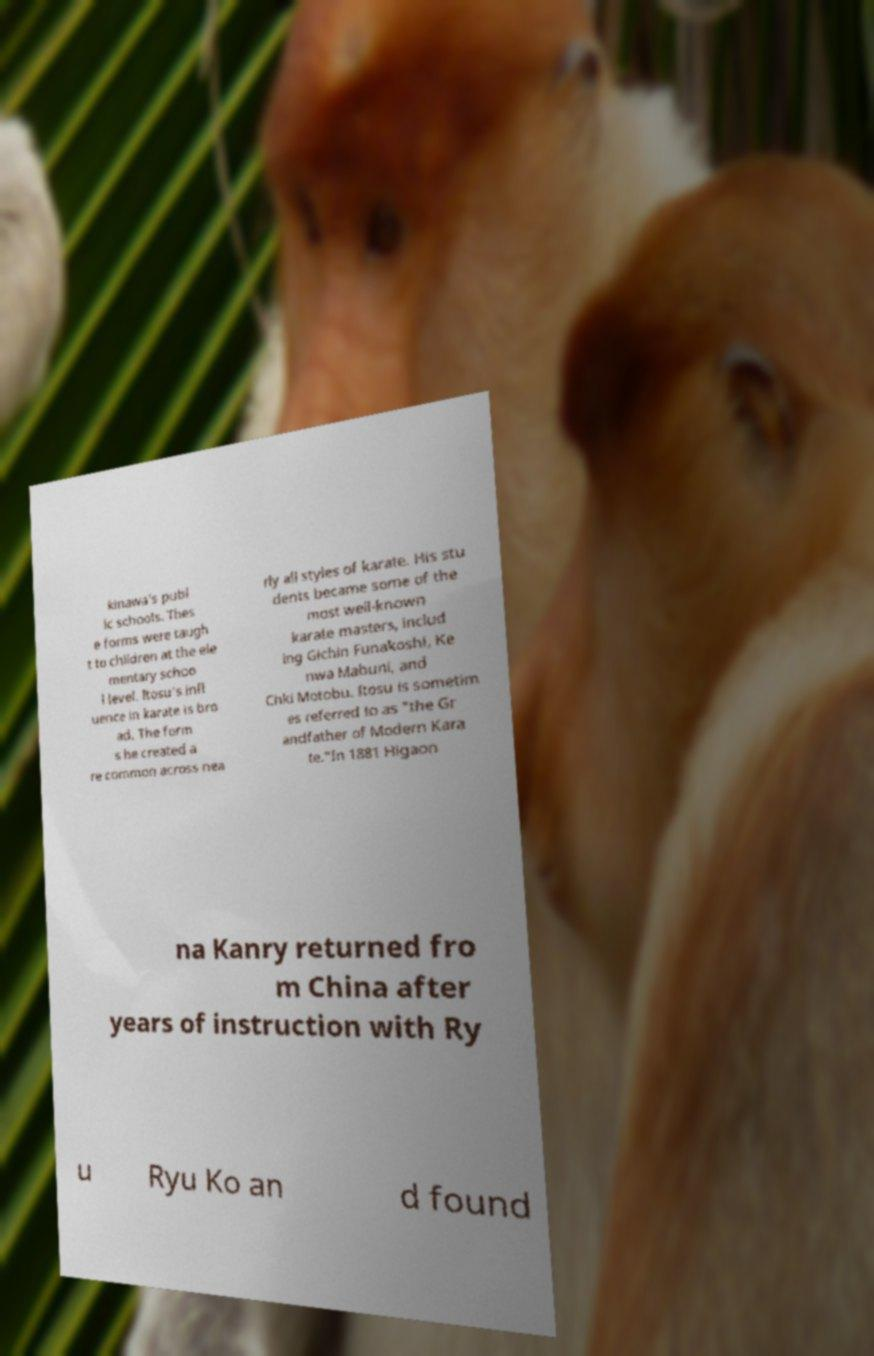What messages or text are displayed in this image? I need them in a readable, typed format. kinawa's publ ic schools. Thes e forms were taugh t to children at the ele mentary schoo l level. Itosu's infl uence in karate is bro ad. The form s he created a re common across nea rly all styles of karate. His stu dents became some of the most well-known karate masters, includ ing Gichin Funakoshi, Ke nwa Mabuni, and Chki Motobu. Itosu is sometim es referred to as "the Gr andfather of Modern Kara te."In 1881 Higaon na Kanry returned fro m China after years of instruction with Ry u Ryu Ko an d found 